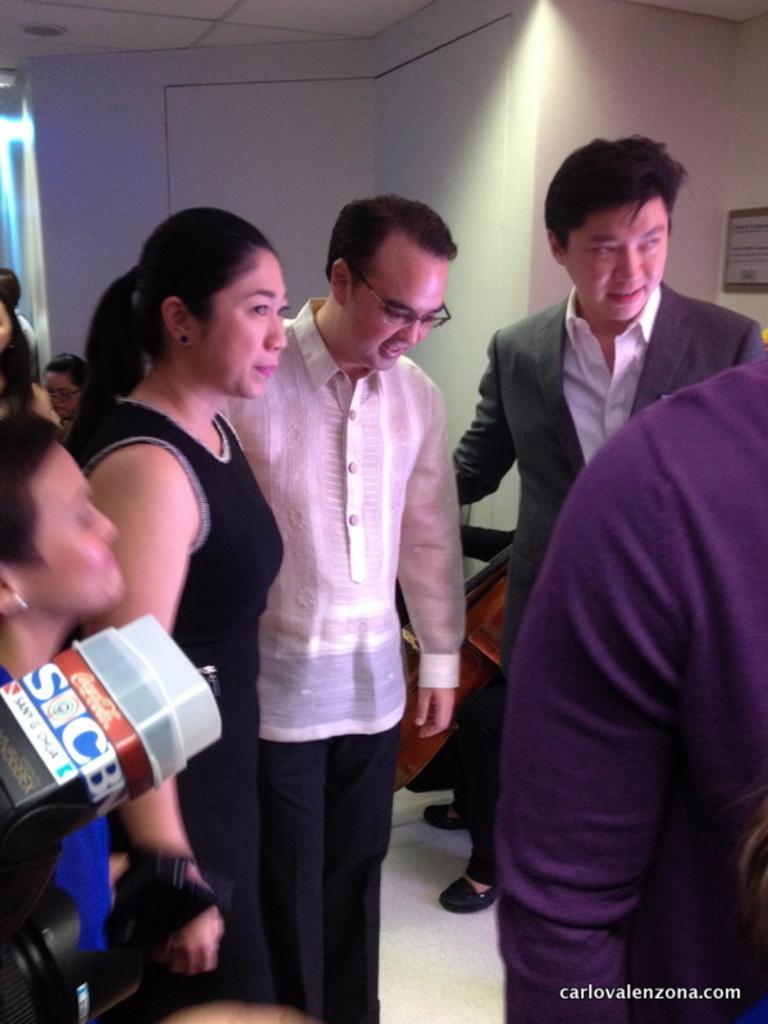In one or two sentences, can you explain what this image depicts? In the image there are few people standing. On the left side there is a camera. In the background there is a white wall. At the bottom of the image there is a watermark. 